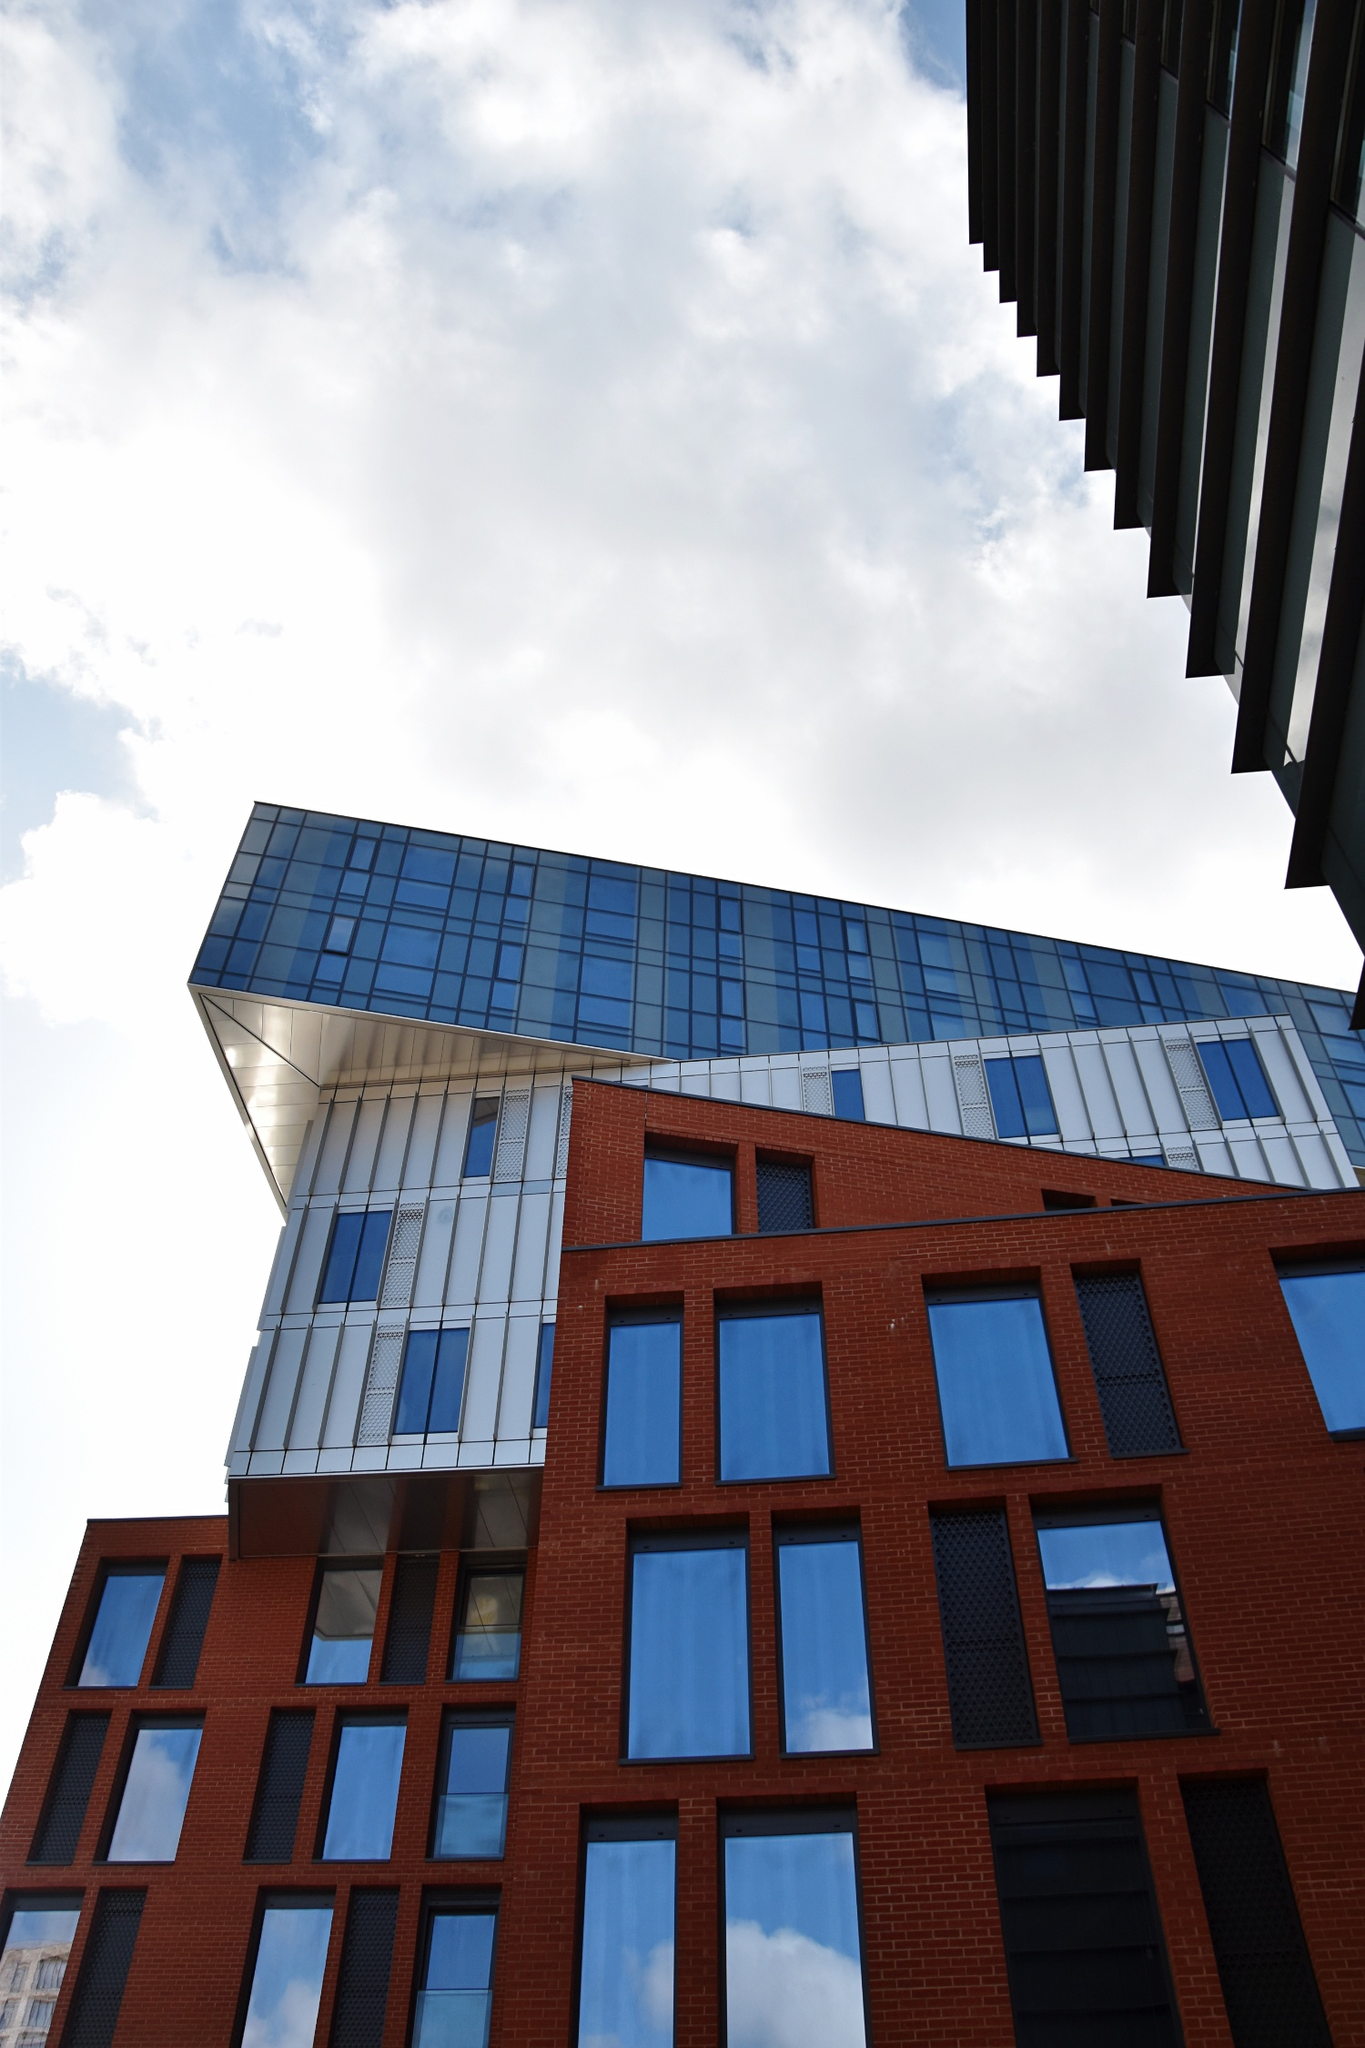How does the architectural design of the building reflect modern trends in architecture? The design of the building showcases several elements that are characteristic of contemporary architecture. One prominent trend reflected in the structure is the integration of traditional materials, such as red brick, with modern elements like glass and steel, creating a blend that respects the past while embracing the future. The use of large, blue-tinted glass panels allows natural light to flood the interiors while providing reflective surfaces that echo the surrounding environment. Furthermore, the dynamic angles and irregular forms, such as the cantilevered glass tower, provide a sense of movement and innovation, breaking away from the traditional box-like structures. These elements create a visually engaging and functional space that aligns with the current architectural emphasis on sustainability, light, and innovative use of materials. 